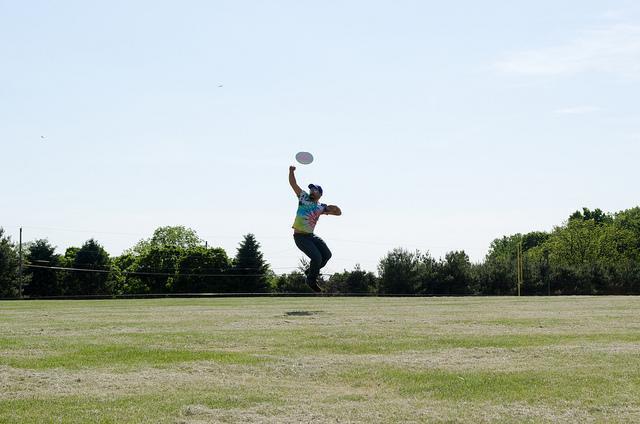How many people are in the image?
Give a very brief answer. 1. 